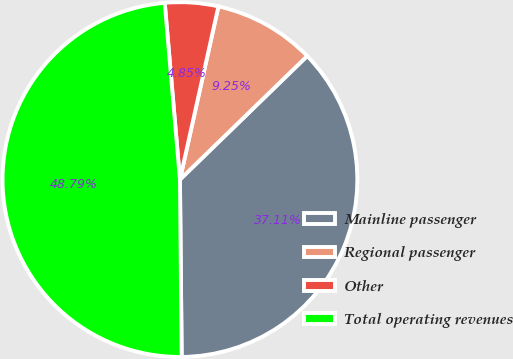<chart> <loc_0><loc_0><loc_500><loc_500><pie_chart><fcel>Mainline passenger<fcel>Regional passenger<fcel>Other<fcel>Total operating revenues<nl><fcel>37.11%<fcel>9.25%<fcel>4.85%<fcel>48.79%<nl></chart> 